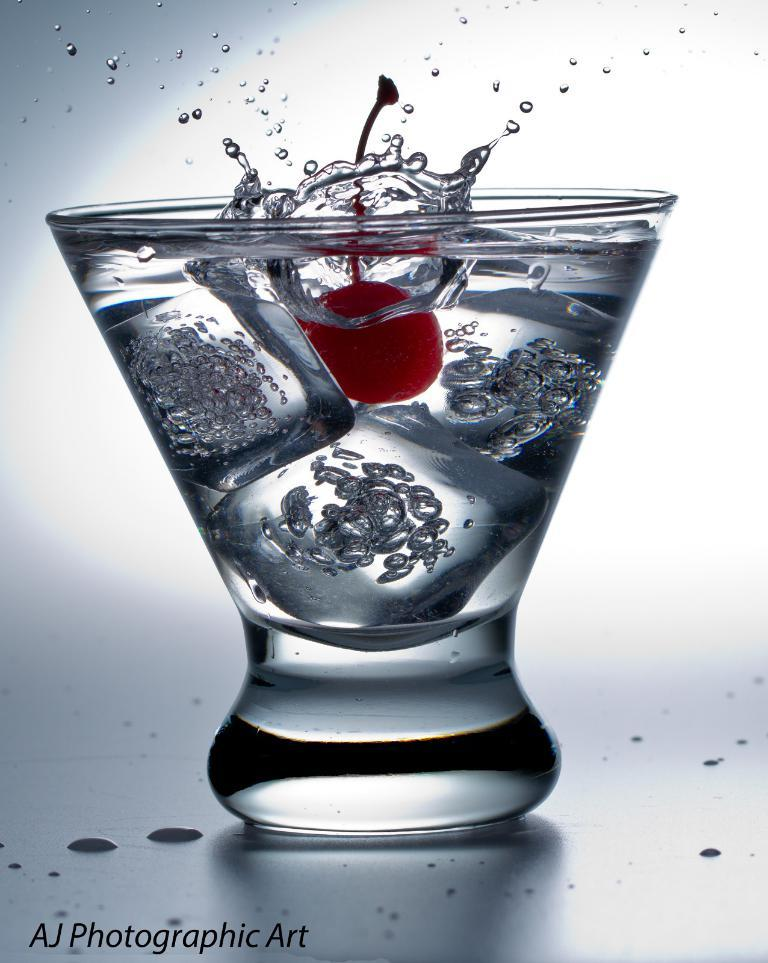What is in the glass that is visible in the image? There are ice cubes, a cherry, and a drink in the glass. What else can be seen in the glass besides the ice cubes and cherry? There is a drink in the glass. Where is the text located in the image? The text is at the left bottom of the image. How many circles can be seen in the image? There is no circle present in the image. What type of tin is visible in the image? There is no tin present in the image. 